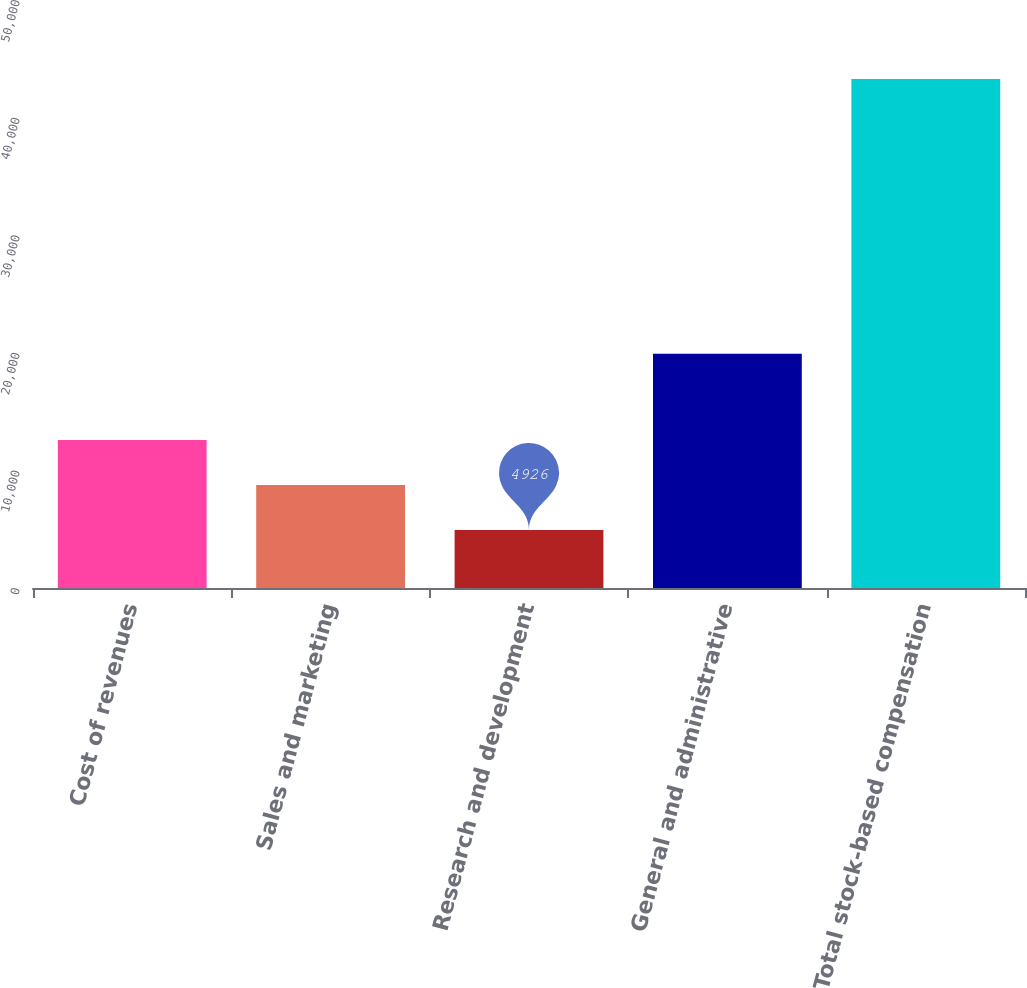Convert chart to OTSL. <chart><loc_0><loc_0><loc_500><loc_500><bar_chart><fcel>Cost of revenues<fcel>Sales and marketing<fcel>Research and development<fcel>General and administrative<fcel>Total stock-based compensation<nl><fcel>12595.2<fcel>8760.6<fcel>4926<fcel>19928<fcel>43272<nl></chart> 